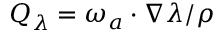Convert formula to latex. <formula><loc_0><loc_0><loc_500><loc_500>Q _ { \lambda } = \omega _ { a } \cdot \nabla \lambda / \rho</formula> 